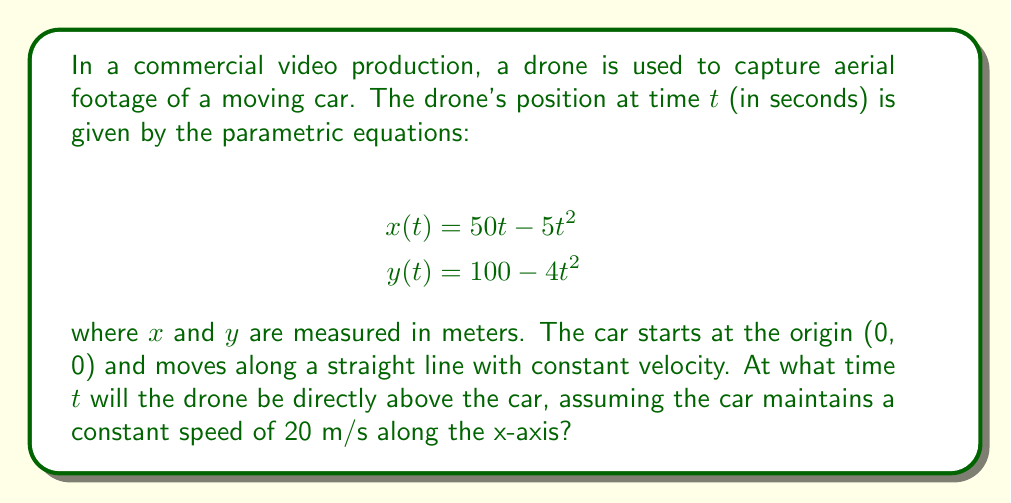Could you help me with this problem? To solve this problem, we need to follow these steps:

1) First, let's express the car's position as a function of time. Since the car moves along the x-axis at a constant speed of 20 m/s, its position at time $t$ is:

   $$x_{car}(t) = 20t$$
   $$y_{car}(t) = 0$$

2) For the drone to be directly above the car, their x-coordinates must be equal:

   $$50t - 5t^2 = 20t$$

3) Let's rearrange this equation:

   $$5t^2 - 30t = 0$$

4) Factor out the common factor:

   $$5t(t - 6) = 0$$

5) Solve this equation:
   
   $t = 0$ or $t = 6$

6) $t = 0$ is not a valid solution as the drone starts at $x = 0$ while the car is already moving. Therefore, $t = 6$ is our solution.

7) To verify, let's check the y-coordinate of the drone at $t = 6$:

   $$y(6) = 100 - 4(6)^2 = 100 - 144 = -44$$

This negative y-value confirms that the drone is above the ground (remember, y = 0 is ground level).

Therefore, the drone will be directly above the car at $t = 6$ seconds.
Answer: The drone will be directly above the car at $t = 6$ seconds. 